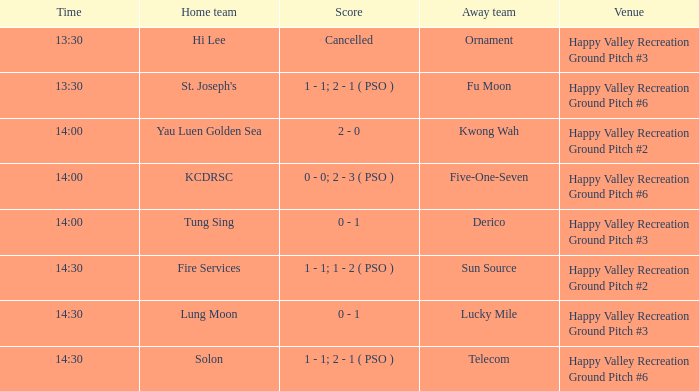What is the score of the match at happy valley recreation ground pitch #2 with a 14:30 time? 1 - 1; 1 - 2 ( PSO ). 